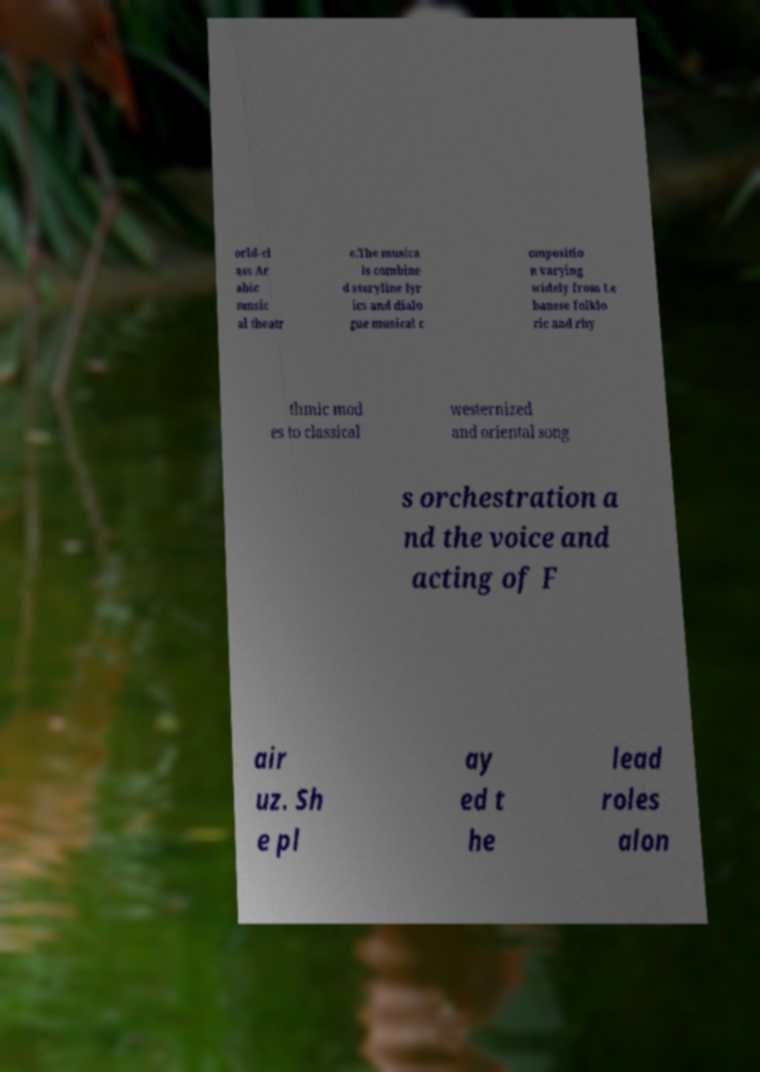Could you assist in decoding the text presented in this image and type it out clearly? orld-cl ass Ar abic music al theatr e.The musica ls combine d storyline lyr ics and dialo gue musical c ompositio n varying widely from Le banese folklo ric and rhy thmic mod es to classical westernized and oriental song s orchestration a nd the voice and acting of F air uz. Sh e pl ay ed t he lead roles alon 